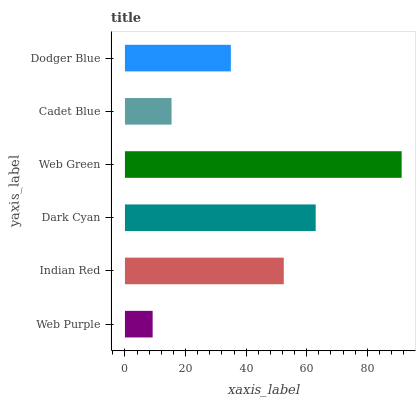Is Web Purple the minimum?
Answer yes or no. Yes. Is Web Green the maximum?
Answer yes or no. Yes. Is Indian Red the minimum?
Answer yes or no. No. Is Indian Red the maximum?
Answer yes or no. No. Is Indian Red greater than Web Purple?
Answer yes or no. Yes. Is Web Purple less than Indian Red?
Answer yes or no. Yes. Is Web Purple greater than Indian Red?
Answer yes or no. No. Is Indian Red less than Web Purple?
Answer yes or no. No. Is Indian Red the high median?
Answer yes or no. Yes. Is Dodger Blue the low median?
Answer yes or no. Yes. Is Web Green the high median?
Answer yes or no. No. Is Web Green the low median?
Answer yes or no. No. 